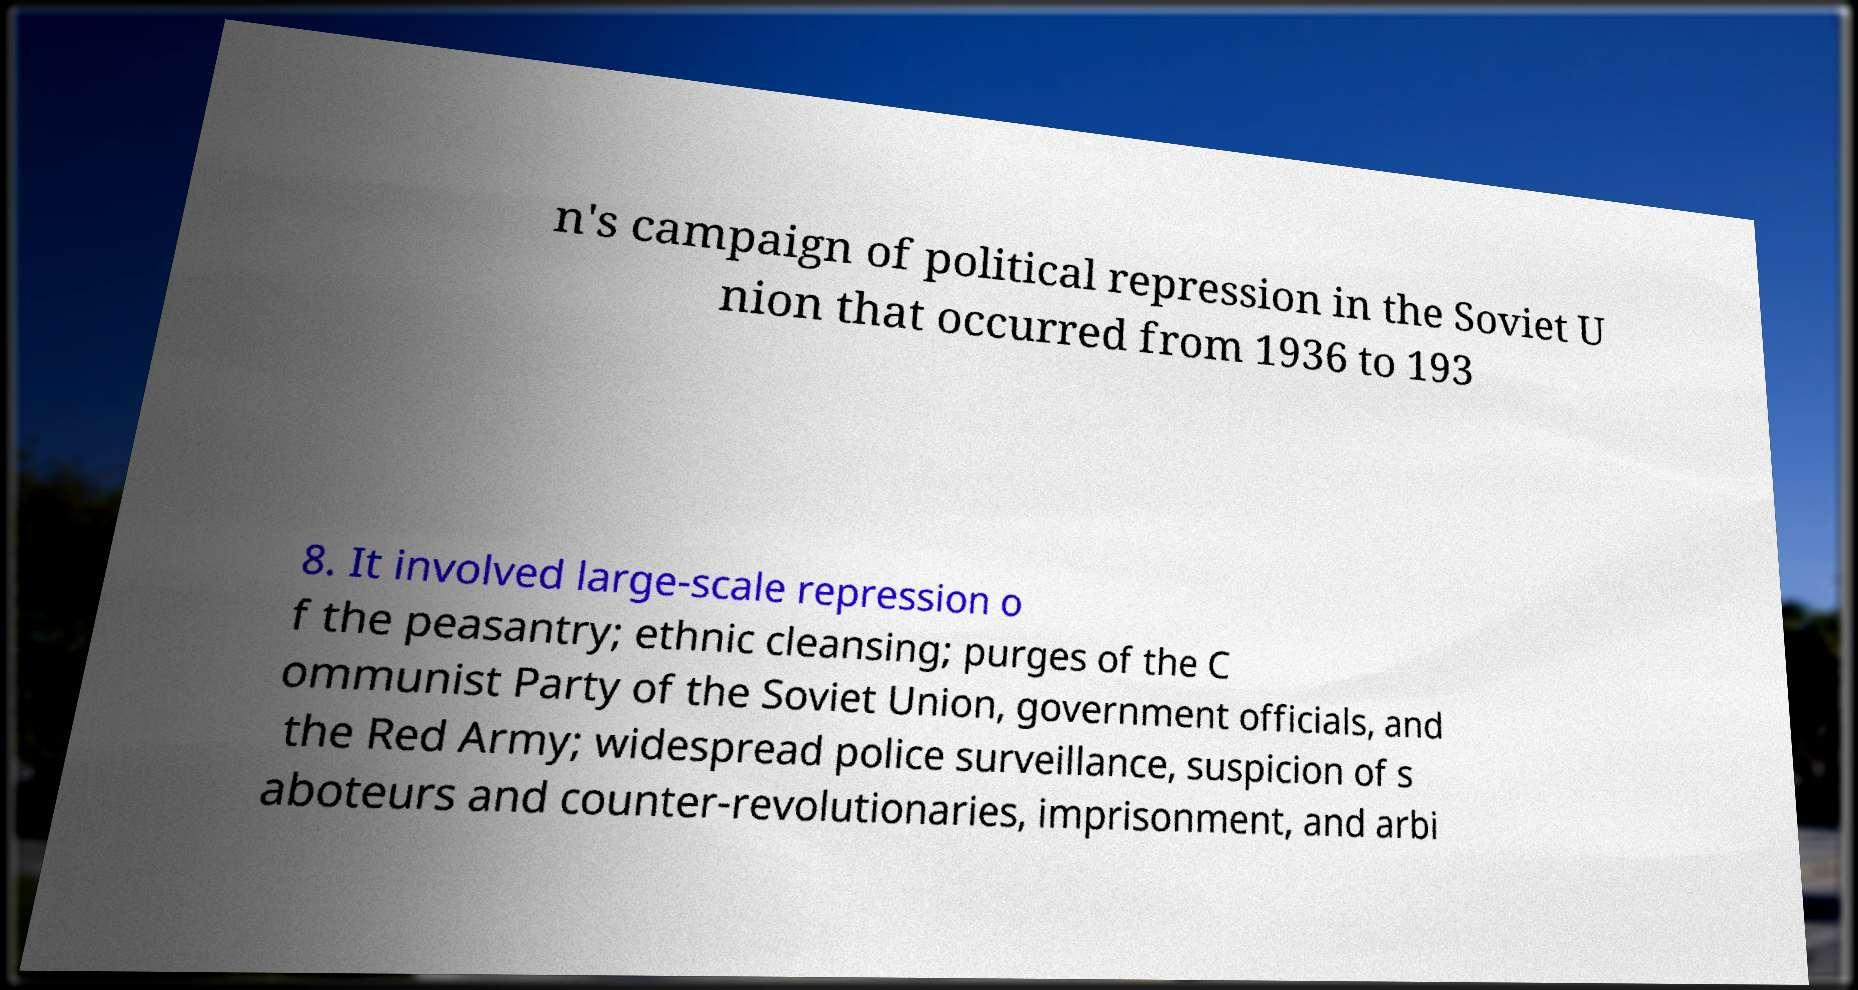Please read and relay the text visible in this image. What does it say? n's campaign of political repression in the Soviet U nion that occurred from 1936 to 193 8. It involved large-scale repression o f the peasantry; ethnic cleansing; purges of the C ommunist Party of the Soviet Union, government officials, and the Red Army; widespread police surveillance, suspicion of s aboteurs and counter-revolutionaries, imprisonment, and arbi 